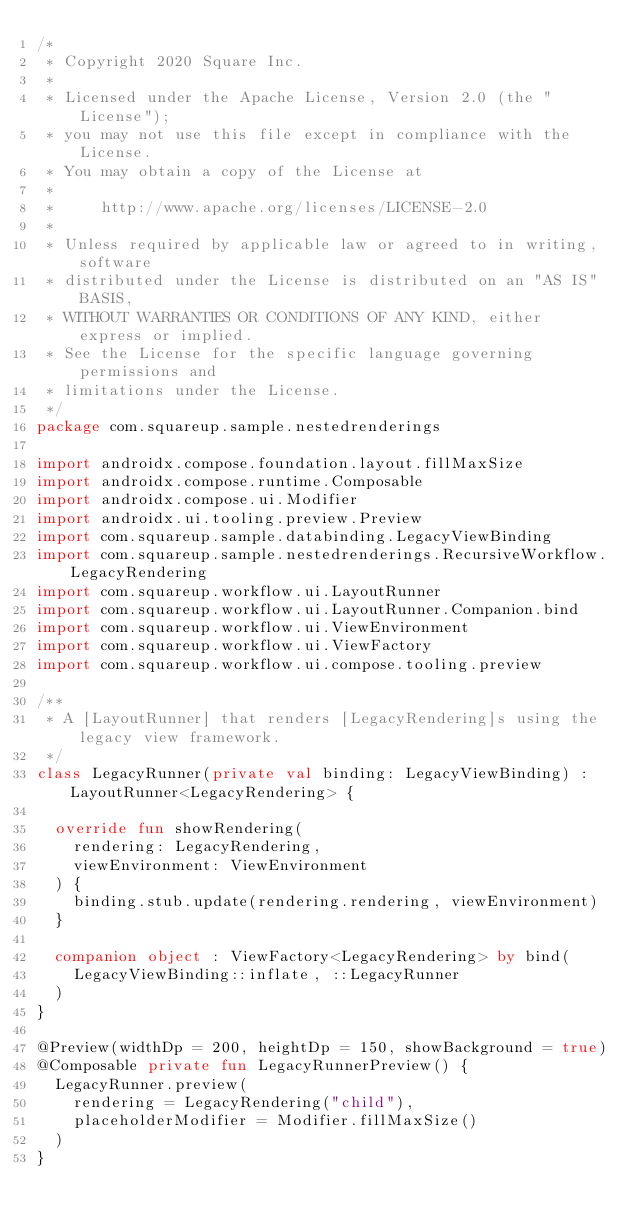Convert code to text. <code><loc_0><loc_0><loc_500><loc_500><_Kotlin_>/*
 * Copyright 2020 Square Inc.
 *
 * Licensed under the Apache License, Version 2.0 (the "License");
 * you may not use this file except in compliance with the License.
 * You may obtain a copy of the License at
 *
 *     http://www.apache.org/licenses/LICENSE-2.0
 *
 * Unless required by applicable law or agreed to in writing, software
 * distributed under the License is distributed on an "AS IS" BASIS,
 * WITHOUT WARRANTIES OR CONDITIONS OF ANY KIND, either express or implied.
 * See the License for the specific language governing permissions and
 * limitations under the License.
 */
package com.squareup.sample.nestedrenderings

import androidx.compose.foundation.layout.fillMaxSize
import androidx.compose.runtime.Composable
import androidx.compose.ui.Modifier
import androidx.ui.tooling.preview.Preview
import com.squareup.sample.databinding.LegacyViewBinding
import com.squareup.sample.nestedrenderings.RecursiveWorkflow.LegacyRendering
import com.squareup.workflow.ui.LayoutRunner
import com.squareup.workflow.ui.LayoutRunner.Companion.bind
import com.squareup.workflow.ui.ViewEnvironment
import com.squareup.workflow.ui.ViewFactory
import com.squareup.workflow.ui.compose.tooling.preview

/**
 * A [LayoutRunner] that renders [LegacyRendering]s using the legacy view framework.
 */
class LegacyRunner(private val binding: LegacyViewBinding) : LayoutRunner<LegacyRendering> {

  override fun showRendering(
    rendering: LegacyRendering,
    viewEnvironment: ViewEnvironment
  ) {
    binding.stub.update(rendering.rendering, viewEnvironment)
  }

  companion object : ViewFactory<LegacyRendering> by bind(
    LegacyViewBinding::inflate, ::LegacyRunner
  )
}

@Preview(widthDp = 200, heightDp = 150, showBackground = true)
@Composable private fun LegacyRunnerPreview() {
  LegacyRunner.preview(
    rendering = LegacyRendering("child"),
    placeholderModifier = Modifier.fillMaxSize()
  )
}
</code> 